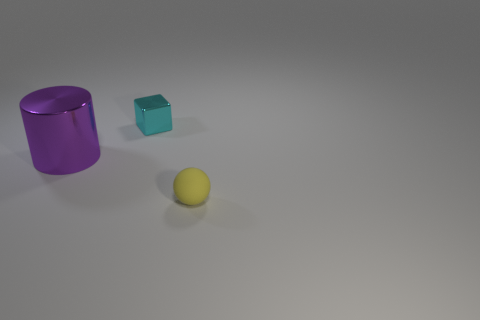There is a thing that is to the left of the rubber thing and in front of the tiny cyan thing; what material is it?
Offer a terse response. Metal. Are the small yellow object and the big purple cylinder made of the same material?
Your response must be concise. No. There is a cyan cube that is the same size as the yellow matte object; what is it made of?
Ensure brevity in your answer.  Metal. How many things are small objects that are to the right of the cube or tiny cyan metallic objects?
Provide a succinct answer. 2. Is the number of yellow balls that are in front of the small rubber ball the same as the number of big cyan things?
Provide a succinct answer. Yes. Is the color of the large metallic cylinder the same as the tiny rubber sphere?
Your answer should be compact. No. The object that is both to the left of the small yellow ball and in front of the tiny metallic thing is what color?
Your answer should be compact. Purple. What number of cubes are either rubber things or big objects?
Provide a short and direct response. 0. Is the number of purple cylinders behind the small cyan metal thing less than the number of tiny balls?
Provide a succinct answer. Yes. What is the shape of the small object that is made of the same material as the big cylinder?
Provide a succinct answer. Cube. 